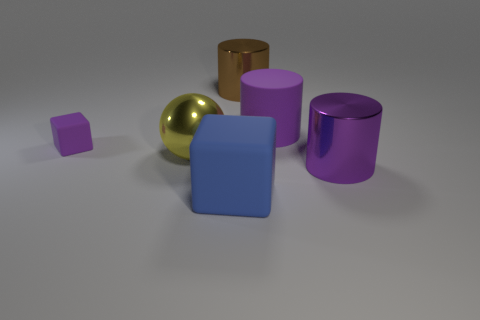Subtract all matte cylinders. How many cylinders are left? 2 Add 2 rubber cylinders. How many objects exist? 8 Subtract 2 blocks. How many blocks are left? 0 Subtract all yellow spheres. How many purple cylinders are left? 2 Subtract all blocks. How many objects are left? 4 Add 3 small yellow spheres. How many small yellow spheres exist? 3 Subtract all purple cylinders. How many cylinders are left? 1 Subtract 1 blue blocks. How many objects are left? 5 Subtract all brown cubes. Subtract all yellow cylinders. How many cubes are left? 2 Subtract all purple blocks. Subtract all big rubber blocks. How many objects are left? 4 